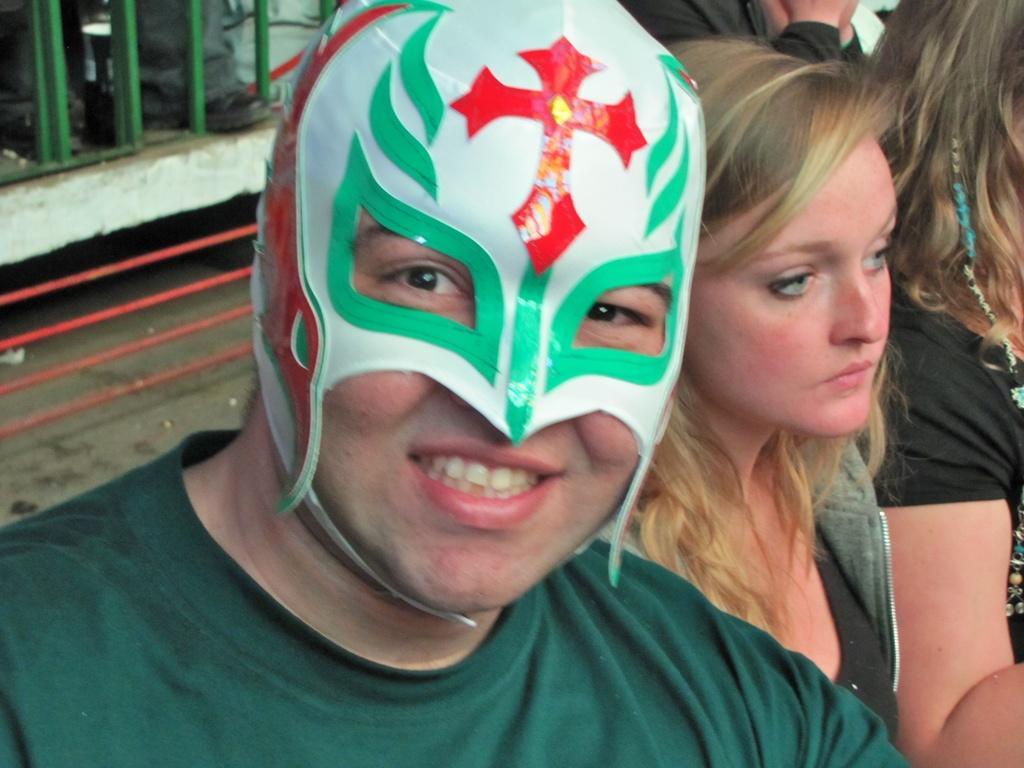How would you summarize this image in a sentence or two? Here I can see a man wearing a mask to the face, smiling and giving pose for the picture. Beside him two women are sitting. On the left side there are few metal rods. At the top of the image I can see a person's hands. 